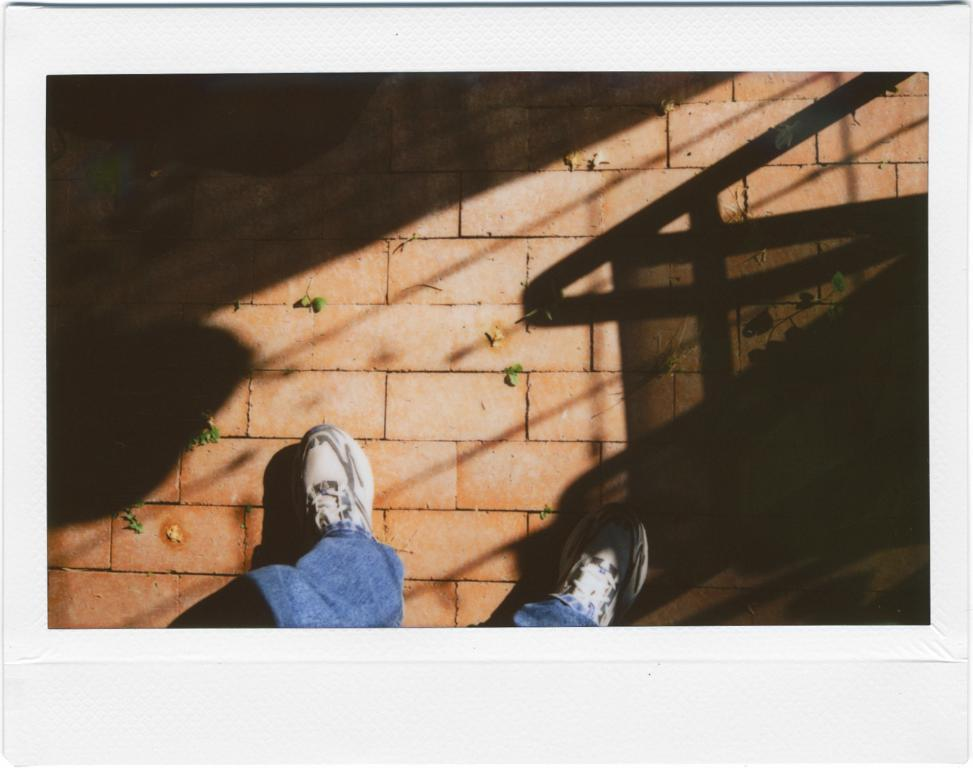What part of a person can be seen in the image? There are legs of a person visible in the image. What type of footwear is the person wearing? The person is wearing shoes. What type of natural elements can be seen on the floor in the image? There are leaves on the floor in the image. What can be observed in the image that indicates the presence of light? Shadows are present in the image. What type of blade is being used by the actor in the image? There is no actor or blade present in the image. What statement is being made by the person in the image? The image does not contain any text or dialogue, so it is not possible to determine any statements being made. 